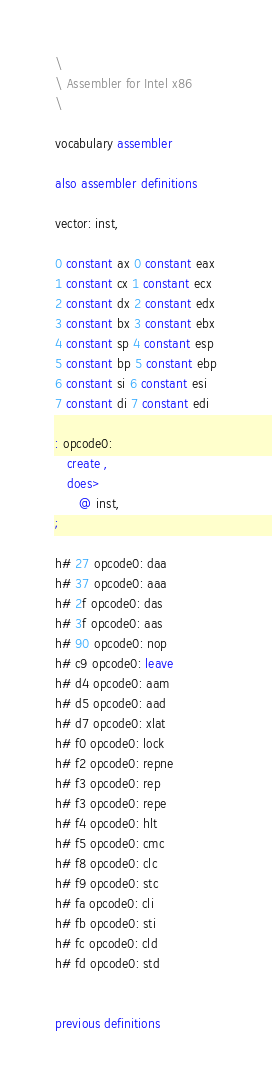Convert code to text. <code><loc_0><loc_0><loc_500><loc_500><_Forth_>\
\ Assembler for Intel x86
\

vocabulary assembler

also assembler definitions

vector: inst,

0 constant ax 0 constant eax
1 constant cx 1 constant ecx
2 constant dx 2 constant edx
3 constant bx 3 constant ebx
4 constant sp 4 constant esp
5 constant bp 5 constant ebp
6 constant si 6 constant esi
7 constant di 7 constant edi

: opcode0:
   create ,
   does>
      @ inst,
;

h# 27 opcode0: daa
h# 37 opcode0: aaa
h# 2f opcode0: das
h# 3f opcode0: aas
h# 90 opcode0: nop
h# c9 opcode0: leave
h# d4 opcode0: aam
h# d5 opcode0: aad
h# d7 opcode0: xlat
h# f0 opcode0: lock
h# f2 opcode0: repne
h# f3 opcode0: rep
h# f3 opcode0: repe
h# f4 opcode0: hlt
h# f5 opcode0: cmc
h# f8 opcode0: clc
h# f9 opcode0: stc
h# fa opcode0: cli
h# fb opcode0: sti
h# fc opcode0: cld
h# fd opcode0: std


previous definitions
</code> 